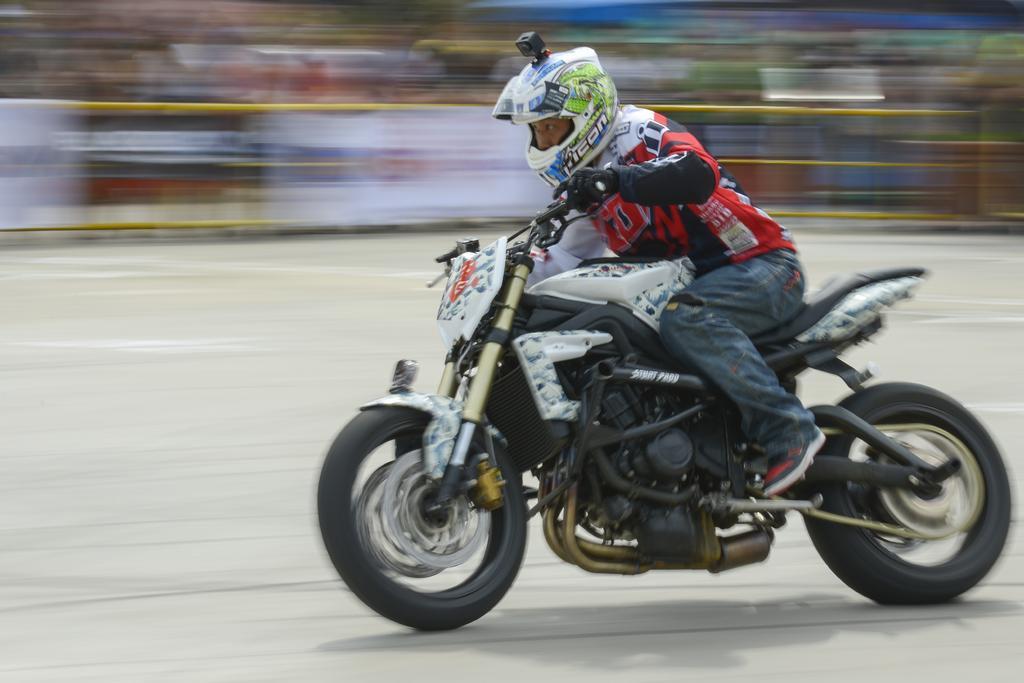Can you describe this image briefly? In this image I can see the person riding the motorbike on the road. The person is wearing the red, black and blue color dress. And I can see the blurred background. 